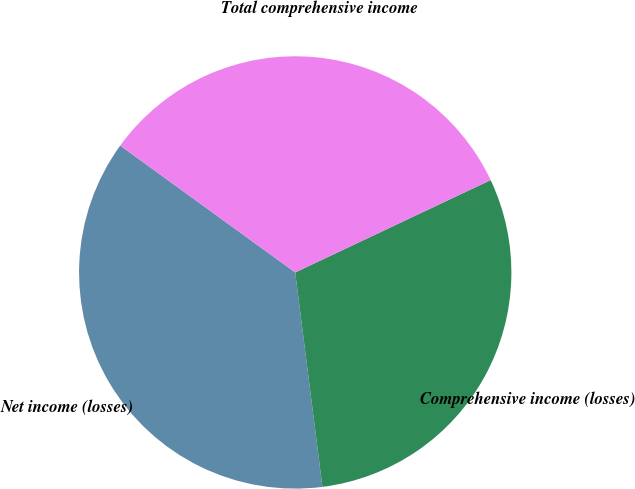Convert chart to OTSL. <chart><loc_0><loc_0><loc_500><loc_500><pie_chart><fcel>Net income (losses)<fcel>Comprehensive income (losses)<fcel>Total comprehensive income<nl><fcel>36.99%<fcel>30.02%<fcel>32.99%<nl></chart> 